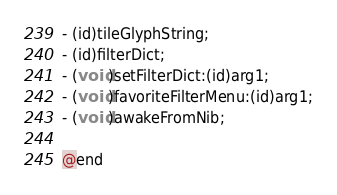Convert code to text. <code><loc_0><loc_0><loc_500><loc_500><_C_>- (id)tileGlyphString;
- (id)filterDict;
- (void)setFilterDict:(id)arg1;
- (void)favoriteFilterMenu:(id)arg1;
- (void)awakeFromNib;

@end

</code> 